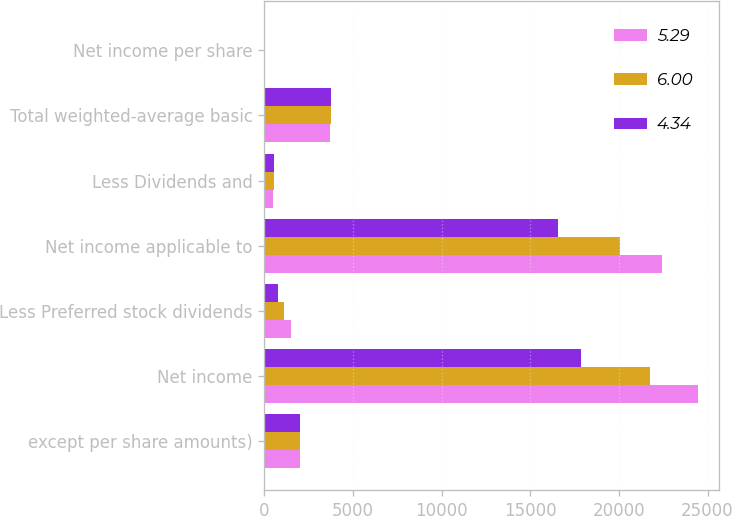Convert chart to OTSL. <chart><loc_0><loc_0><loc_500><loc_500><stacked_bar_chart><ecel><fcel>except per share amounts)<fcel>Net income<fcel>Less Preferred stock dividends<fcel>Net income applicable to<fcel>Less Dividends and<fcel>Total weighted-average basic<fcel>Net income per share<nl><fcel>5.29<fcel>2015<fcel>24442<fcel>1515<fcel>22406<fcel>521<fcel>3700.4<fcel>6.05<nl><fcel>6<fcel>2014<fcel>21745<fcel>1125<fcel>20077<fcel>543<fcel>3763.5<fcel>5.33<nl><fcel>4.34<fcel>2013<fcel>17886<fcel>805<fcel>16557<fcel>524<fcel>3782.4<fcel>4.38<nl></chart> 